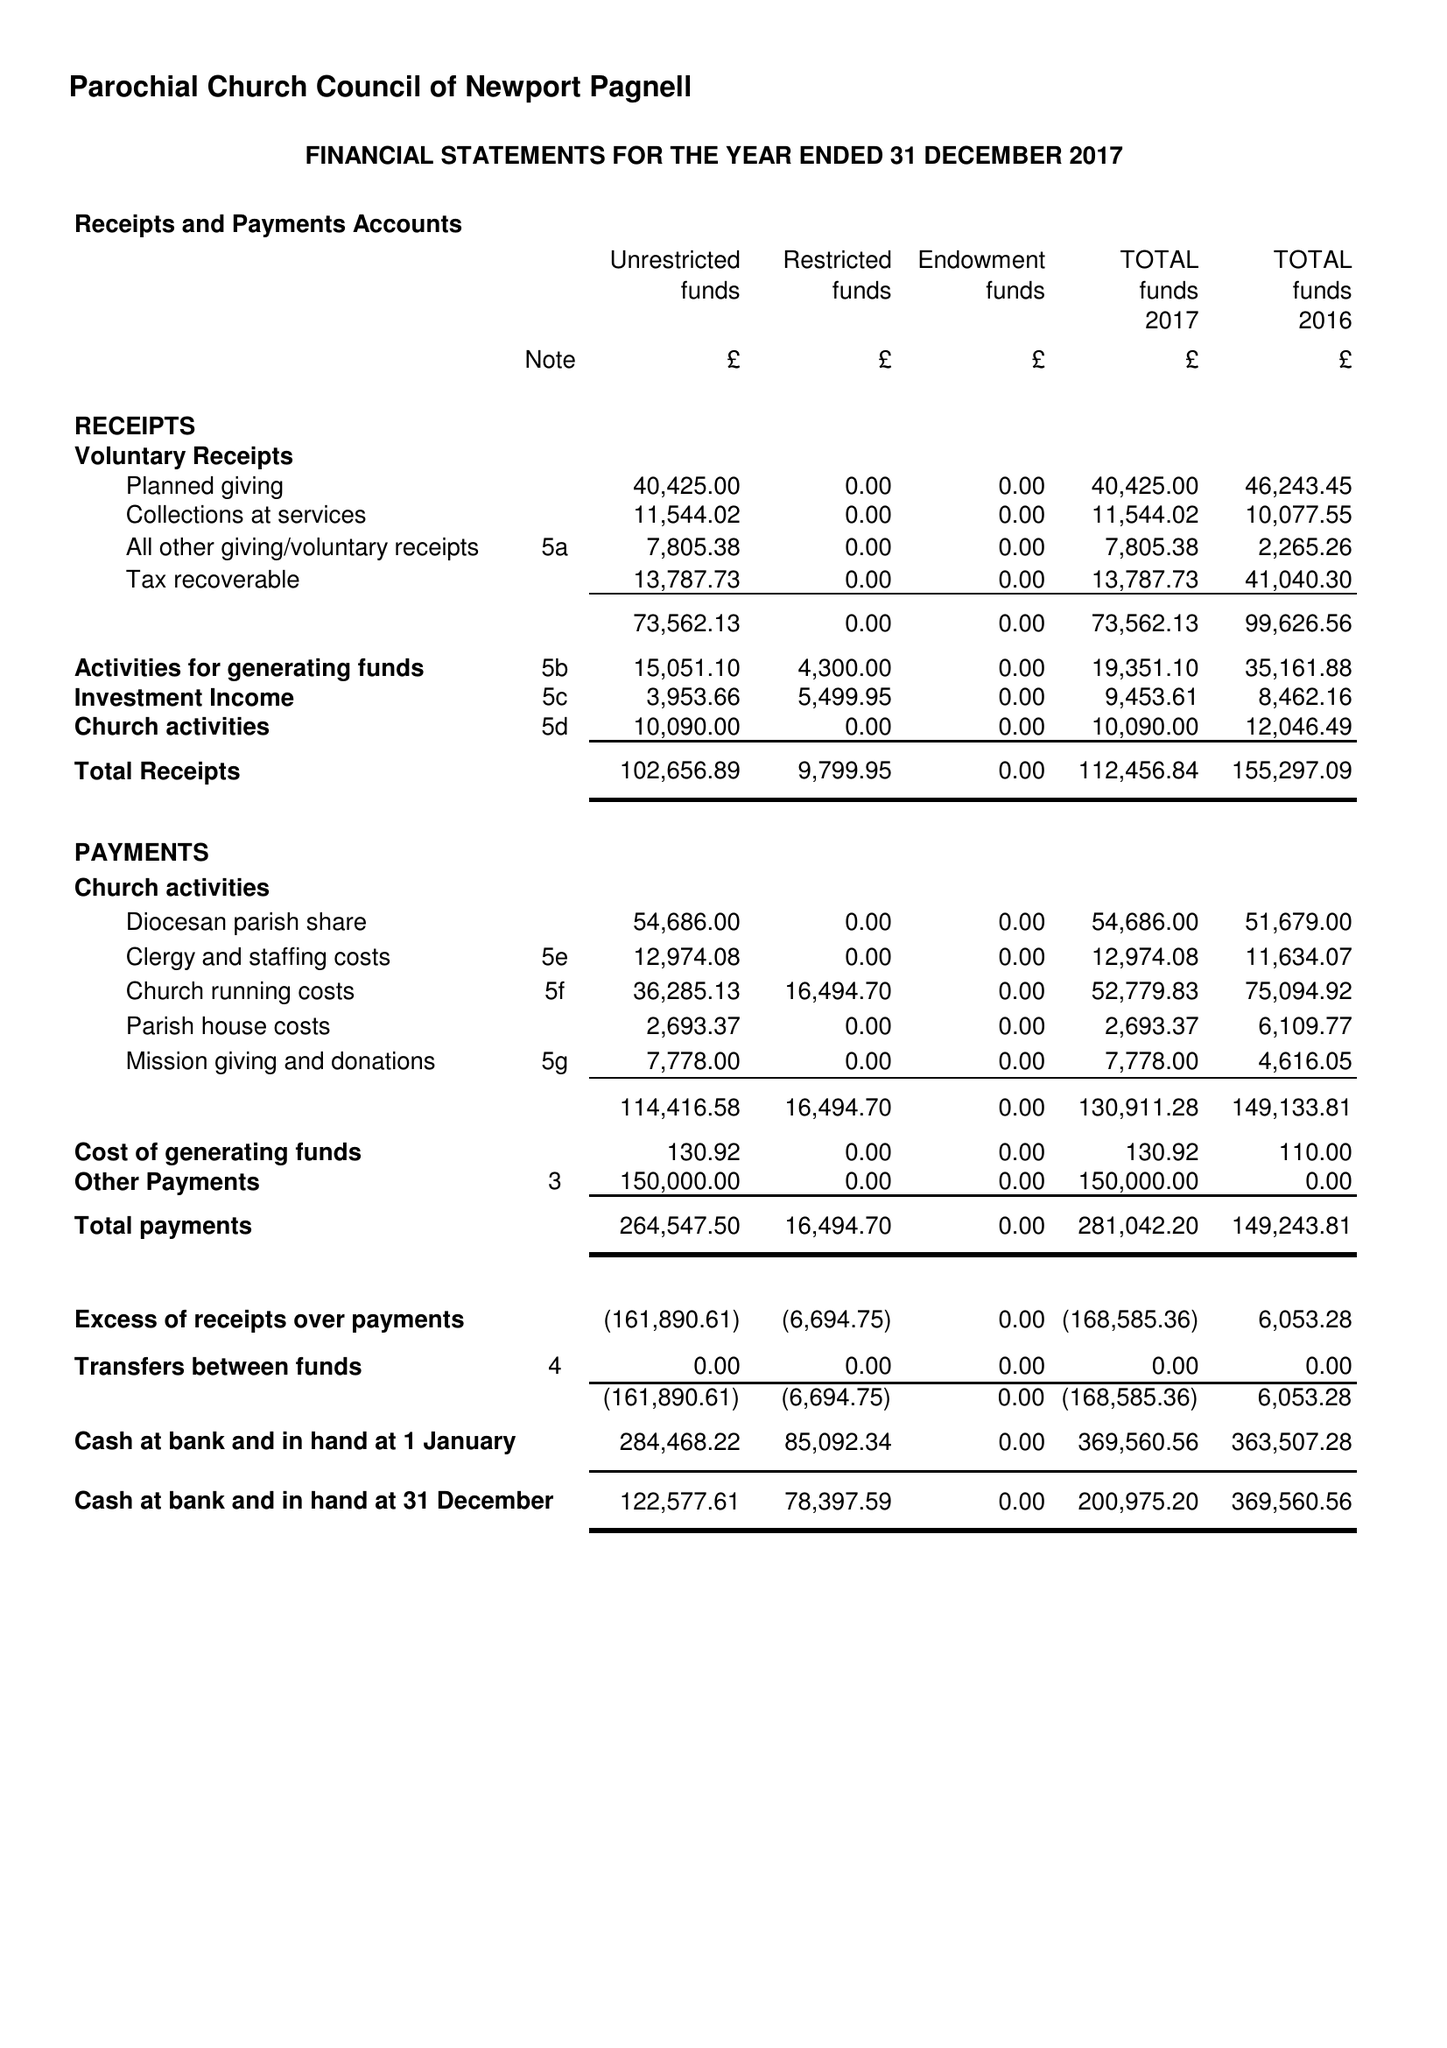What is the value for the report_date?
Answer the question using a single word or phrase. 2017-12-31 